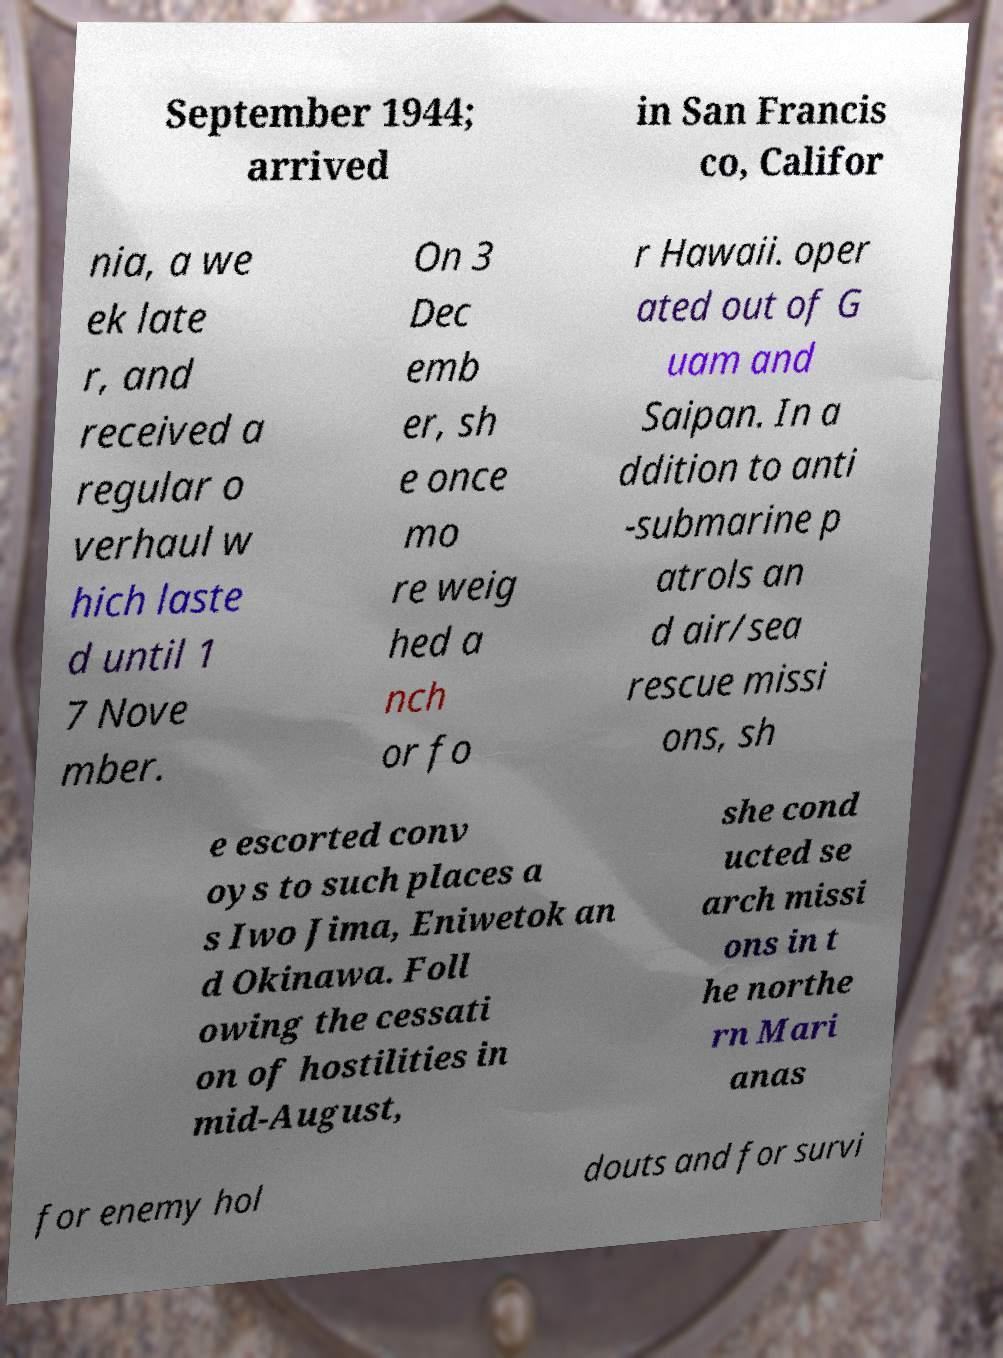Can you accurately transcribe the text from the provided image for me? September 1944; arrived in San Francis co, Califor nia, a we ek late r, and received a regular o verhaul w hich laste d until 1 7 Nove mber. On 3 Dec emb er, sh e once mo re weig hed a nch or fo r Hawaii. oper ated out of G uam and Saipan. In a ddition to anti -submarine p atrols an d air/sea rescue missi ons, sh e escorted conv oys to such places a s Iwo Jima, Eniwetok an d Okinawa. Foll owing the cessati on of hostilities in mid-August, she cond ucted se arch missi ons in t he northe rn Mari anas for enemy hol douts and for survi 